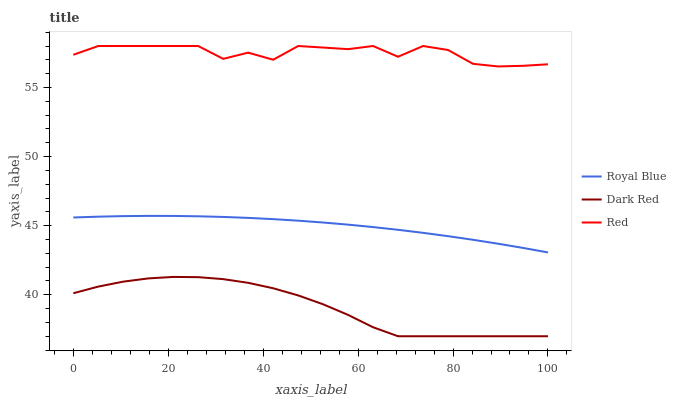Does Dark Red have the minimum area under the curve?
Answer yes or no. Yes. Does Red have the maximum area under the curve?
Answer yes or no. Yes. Does Red have the minimum area under the curve?
Answer yes or no. No. Does Dark Red have the maximum area under the curve?
Answer yes or no. No. Is Royal Blue the smoothest?
Answer yes or no. Yes. Is Red the roughest?
Answer yes or no. Yes. Is Dark Red the smoothest?
Answer yes or no. No. Is Dark Red the roughest?
Answer yes or no. No. Does Dark Red have the lowest value?
Answer yes or no. Yes. Does Red have the lowest value?
Answer yes or no. No. Does Red have the highest value?
Answer yes or no. Yes. Does Dark Red have the highest value?
Answer yes or no. No. Is Dark Red less than Red?
Answer yes or no. Yes. Is Red greater than Royal Blue?
Answer yes or no. Yes. Does Dark Red intersect Red?
Answer yes or no. No. 